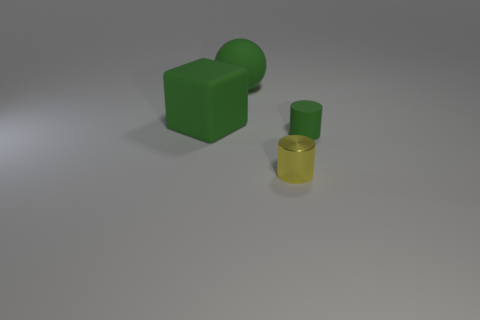Add 3 large cubes. How many objects exist? 7 Subtract all blocks. How many objects are left? 3 Add 3 tiny cylinders. How many tiny cylinders are left? 5 Add 4 tiny rubber cylinders. How many tiny rubber cylinders exist? 5 Subtract 1 green cylinders. How many objects are left? 3 Subtract all purple objects. Subtract all large green objects. How many objects are left? 2 